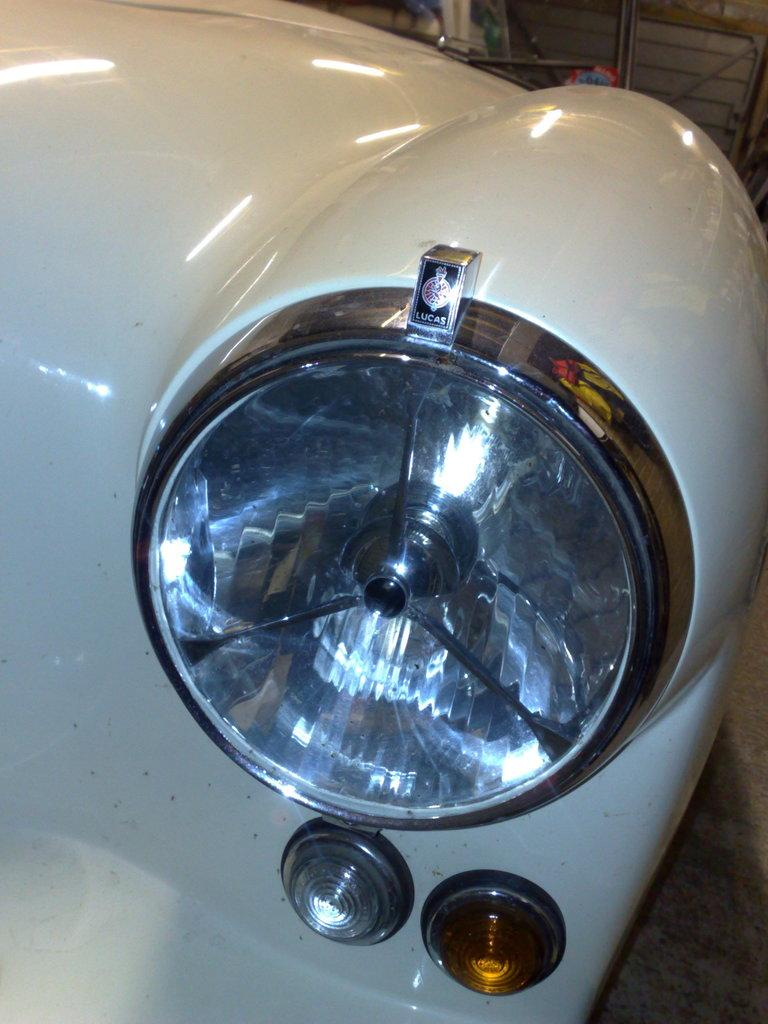What part of a vehicle is visible in the image? There is a headlight of a vehicle in the image. What color is the vehicle? The vehicle is white. Are there any other lights visible in the image? Yes, there are two small lights at the bottom of the image. What type of gun is depicted in the image? There is no gun present in the image; it features a headlight of a vehicle and two small lights. What design elements can be seen in the image? The image does not show any design elements, as it primarily features the headlight of a vehicle and two small lights. 